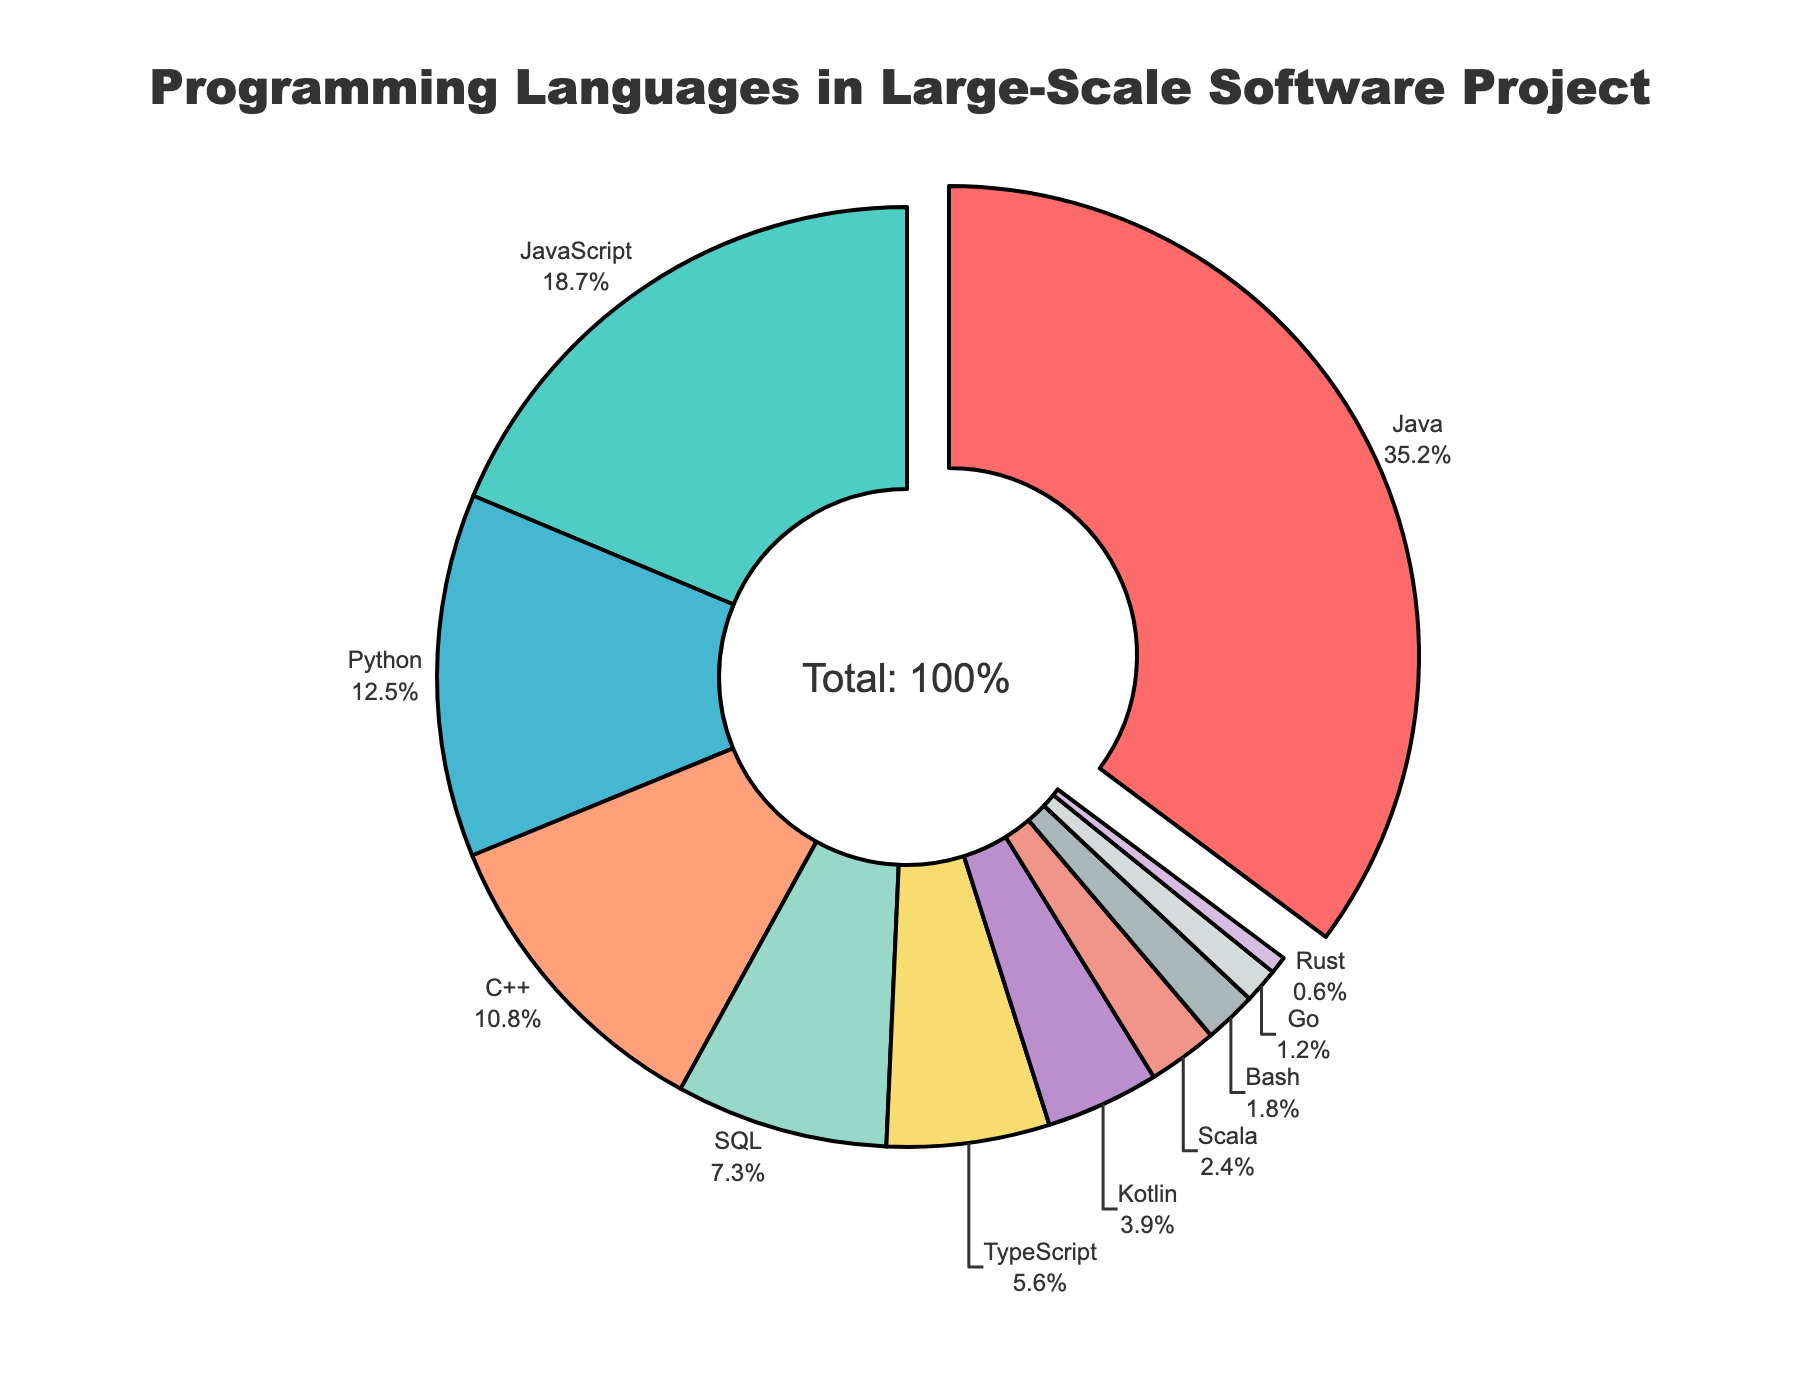What is the most used programming language in the project? The most used programming language is the one with the largest percentage in the pie chart. Java has the largest slice with 35.2%.
Answer: Java Which language has a smaller percentage use: TypeScript or Kotlin? Compare the slices labeled TypeScript and Kotlin. TypeScript has 5.6%, and Kotlin has 3.9%. 3.9% is less than 5.6%.
Answer: Kotlin How much higher is Java's usage compared to Python? Java's usage is 35.2%, and Python's is 12.5%. Subtract Python's percentage from Java's: 35.2% - 12.5% = 22.7%.
Answer: 22.7% What is the combined percentage of JavaScript, Python, and C++ usage? Add the percentages for JavaScript, Python, and C++: 18.7% + 12.5% + 10.8% = 42.0%.
Answer: 42.0% Which language has the smallest proportion, and what is its value? Look for the smallest slice in the chart. Rust has the smallest slice at 0.6%.
Answer: Rust, 0.6% Is there more usage of SQL or TypeScript? Compare the slices for SQL and TypeScript. SQL is at 7.3%, and TypeScript is at 5.6%. 7.3% is greater than 5.6%.
Answer: SQL What is the percentage difference between the least used (Rust) and most used (Java) languages? Subtract the percentage of the least used language (Rust, 0.6%) from the most used language (Java, 35.2%): 35.2% - 0.6% = 34.6%.
Answer: 34.6% How many languages are there with a usage percentage lower than 5%? Identify all slices with percentages lower than 5%: Kotlin (3.9%), Scala (2.4%), Bash (1.8%), Go (1.2%), Rust (0.6%). Count these slices: five languages.
Answer: 5 Can you list all the languages used in the project? Read and list all language labels from the pie chart: Java, JavaScript, Python, C++, SQL, TypeScript, Kotlin, Scala, Bash, Go, Rust.
Answer: Java, JavaScript, Python, C++, SQL, TypeScript, Kotlin, Scala, Bash, Go, Rust 